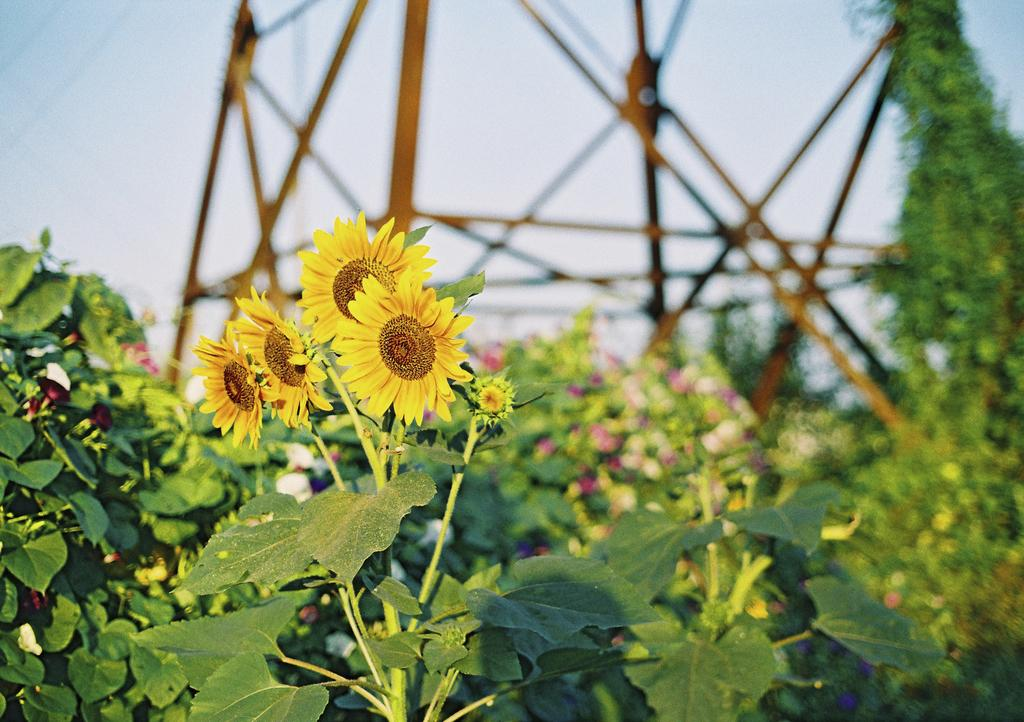What type of living organisms can be seen in the image? Plants can be seen in the image, including yellow flowers. What is visible in the background of the image? There is a tower in the background of the image. How would you describe the quality of the background in the image? The background of the image is blurred. What is the condition of the sky in the image? The sky is clear in the image. What type of lunch is the owner of the plants eating in the image? There is no owner of the plants present in the image, nor is there any indication of anyone eating lunch. 